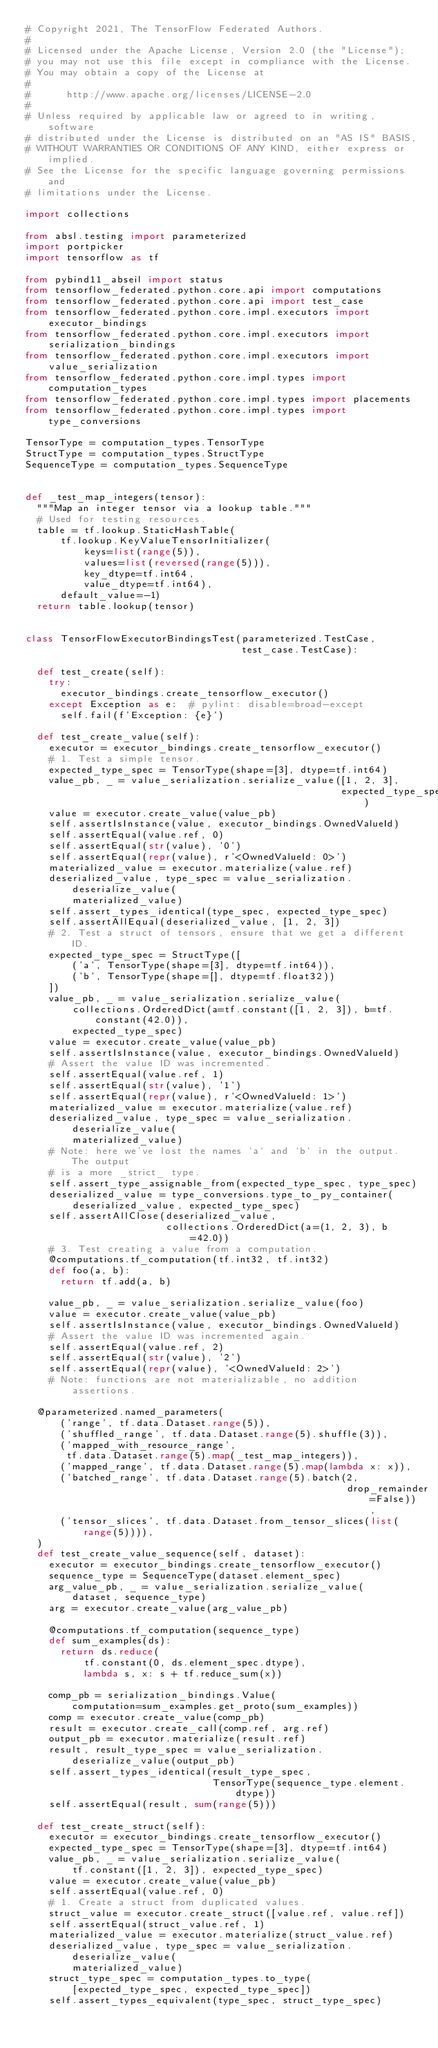<code> <loc_0><loc_0><loc_500><loc_500><_Python_># Copyright 2021, The TensorFlow Federated Authors.
#
# Licensed under the Apache License, Version 2.0 (the "License");
# you may not use this file except in compliance with the License.
# You may obtain a copy of the License at
#
#      http://www.apache.org/licenses/LICENSE-2.0
#
# Unless required by applicable law or agreed to in writing, software
# distributed under the License is distributed on an "AS IS" BASIS,
# WITHOUT WARRANTIES OR CONDITIONS OF ANY KIND, either express or implied.
# See the License for the specific language governing permissions and
# limitations under the License.

import collections

from absl.testing import parameterized
import portpicker
import tensorflow as tf

from pybind11_abseil import status
from tensorflow_federated.python.core.api import computations
from tensorflow_federated.python.core.api import test_case
from tensorflow_federated.python.core.impl.executors import executor_bindings
from tensorflow_federated.python.core.impl.executors import serialization_bindings
from tensorflow_federated.python.core.impl.executors import value_serialization
from tensorflow_federated.python.core.impl.types import computation_types
from tensorflow_federated.python.core.impl.types import placements
from tensorflow_federated.python.core.impl.types import type_conversions

TensorType = computation_types.TensorType
StructType = computation_types.StructType
SequenceType = computation_types.SequenceType


def _test_map_integers(tensor):
  """Map an integer tensor via a lookup table."""
  # Used for testing resources.
  table = tf.lookup.StaticHashTable(
      tf.lookup.KeyValueTensorInitializer(
          keys=list(range(5)),
          values=list(reversed(range(5))),
          key_dtype=tf.int64,
          value_dtype=tf.int64),
      default_value=-1)
  return table.lookup(tensor)


class TensorFlowExecutorBindingsTest(parameterized.TestCase,
                                     test_case.TestCase):

  def test_create(self):
    try:
      executor_bindings.create_tensorflow_executor()
    except Exception as e:  # pylint: disable=broad-except
      self.fail(f'Exception: {e}')

  def test_create_value(self):
    executor = executor_bindings.create_tensorflow_executor()
    # 1. Test a simple tensor.
    expected_type_spec = TensorType(shape=[3], dtype=tf.int64)
    value_pb, _ = value_serialization.serialize_value([1, 2, 3],
                                                      expected_type_spec)
    value = executor.create_value(value_pb)
    self.assertIsInstance(value, executor_bindings.OwnedValueId)
    self.assertEqual(value.ref, 0)
    self.assertEqual(str(value), '0')
    self.assertEqual(repr(value), r'<OwnedValueId: 0>')
    materialized_value = executor.materialize(value.ref)
    deserialized_value, type_spec = value_serialization.deserialize_value(
        materialized_value)
    self.assert_types_identical(type_spec, expected_type_spec)
    self.assertAllEqual(deserialized_value, [1, 2, 3])
    # 2. Test a struct of tensors, ensure that we get a different ID.
    expected_type_spec = StructType([
        ('a', TensorType(shape=[3], dtype=tf.int64)),
        ('b', TensorType(shape=[], dtype=tf.float32))
    ])
    value_pb, _ = value_serialization.serialize_value(
        collections.OrderedDict(a=tf.constant([1, 2, 3]), b=tf.constant(42.0)),
        expected_type_spec)
    value = executor.create_value(value_pb)
    self.assertIsInstance(value, executor_bindings.OwnedValueId)
    # Assert the value ID was incremented.
    self.assertEqual(value.ref, 1)
    self.assertEqual(str(value), '1')
    self.assertEqual(repr(value), r'<OwnedValueId: 1>')
    materialized_value = executor.materialize(value.ref)
    deserialized_value, type_spec = value_serialization.deserialize_value(
        materialized_value)
    # Note: here we've lost the names `a` and `b` in the output. The output
    # is a more _strict_ type.
    self.assert_type_assignable_from(expected_type_spec, type_spec)
    deserialized_value = type_conversions.type_to_py_container(
        deserialized_value, expected_type_spec)
    self.assertAllClose(deserialized_value,
                        collections.OrderedDict(a=(1, 2, 3), b=42.0))
    # 3. Test creating a value from a computation.
    @computations.tf_computation(tf.int32, tf.int32)
    def foo(a, b):
      return tf.add(a, b)

    value_pb, _ = value_serialization.serialize_value(foo)
    value = executor.create_value(value_pb)
    self.assertIsInstance(value, executor_bindings.OwnedValueId)
    # Assert the value ID was incremented again.
    self.assertEqual(value.ref, 2)
    self.assertEqual(str(value), '2')
    self.assertEqual(repr(value), '<OwnedValueId: 2>')
    # Note: functions are not materializable, no addition assertions.

  @parameterized.named_parameters(
      ('range', tf.data.Dataset.range(5)),
      ('shuffled_range', tf.data.Dataset.range(5).shuffle(3)),
      ('mapped_with_resource_range',
       tf.data.Dataset.range(5).map(_test_map_integers)),
      ('mapped_range', tf.data.Dataset.range(5).map(lambda x: x)),
      ('batched_range', tf.data.Dataset.range(5).batch(2,
                                                       drop_remainder=False)),
      ('tensor_slices', tf.data.Dataset.from_tensor_slices(list(range(5)))),
  )
  def test_create_value_sequence(self, dataset):
    executor = executor_bindings.create_tensorflow_executor()
    sequence_type = SequenceType(dataset.element_spec)
    arg_value_pb, _ = value_serialization.serialize_value(
        dataset, sequence_type)
    arg = executor.create_value(arg_value_pb)

    @computations.tf_computation(sequence_type)
    def sum_examples(ds):
      return ds.reduce(
          tf.constant(0, ds.element_spec.dtype),
          lambda s, x: s + tf.reduce_sum(x))

    comp_pb = serialization_bindings.Value(
        computation=sum_examples.get_proto(sum_examples))
    comp = executor.create_value(comp_pb)
    result = executor.create_call(comp.ref, arg.ref)
    output_pb = executor.materialize(result.ref)
    result, result_type_spec = value_serialization.deserialize_value(output_pb)
    self.assert_types_identical(result_type_spec,
                                TensorType(sequence_type.element.dtype))
    self.assertEqual(result, sum(range(5)))

  def test_create_struct(self):
    executor = executor_bindings.create_tensorflow_executor()
    expected_type_spec = TensorType(shape=[3], dtype=tf.int64)
    value_pb, _ = value_serialization.serialize_value(
        tf.constant([1, 2, 3]), expected_type_spec)
    value = executor.create_value(value_pb)
    self.assertEqual(value.ref, 0)
    # 1. Create a struct from duplicated values.
    struct_value = executor.create_struct([value.ref, value.ref])
    self.assertEqual(struct_value.ref, 1)
    materialized_value = executor.materialize(struct_value.ref)
    deserialized_value, type_spec = value_serialization.deserialize_value(
        materialized_value)
    struct_type_spec = computation_types.to_type(
        [expected_type_spec, expected_type_spec])
    self.assert_types_equivalent(type_spec, struct_type_spec)</code> 